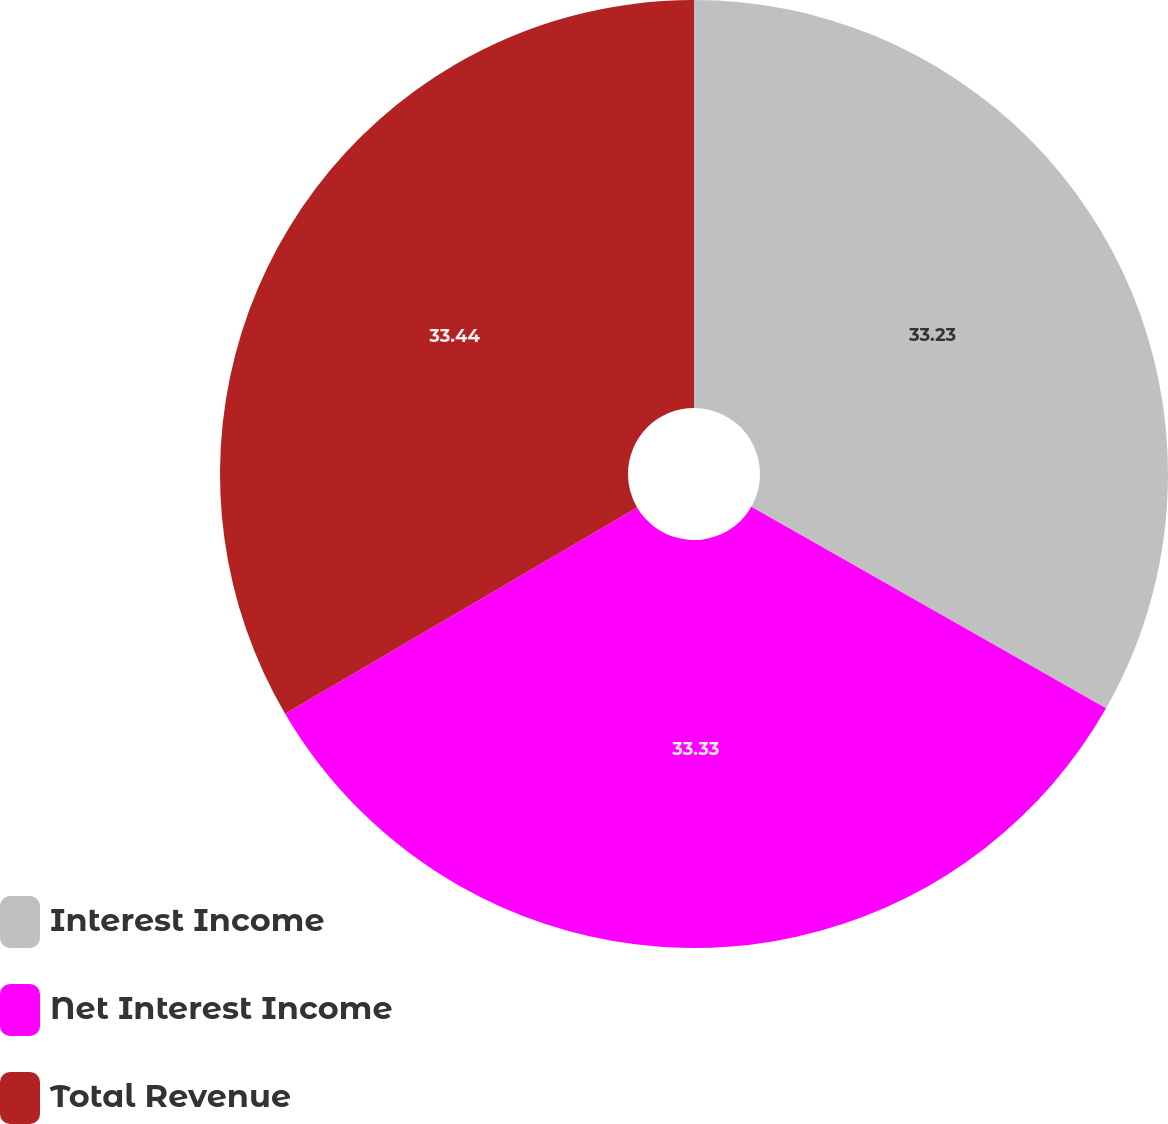Convert chart to OTSL. <chart><loc_0><loc_0><loc_500><loc_500><pie_chart><fcel>Interest Income<fcel>Net Interest Income<fcel>Total Revenue<nl><fcel>33.23%<fcel>33.33%<fcel>33.44%<nl></chart> 